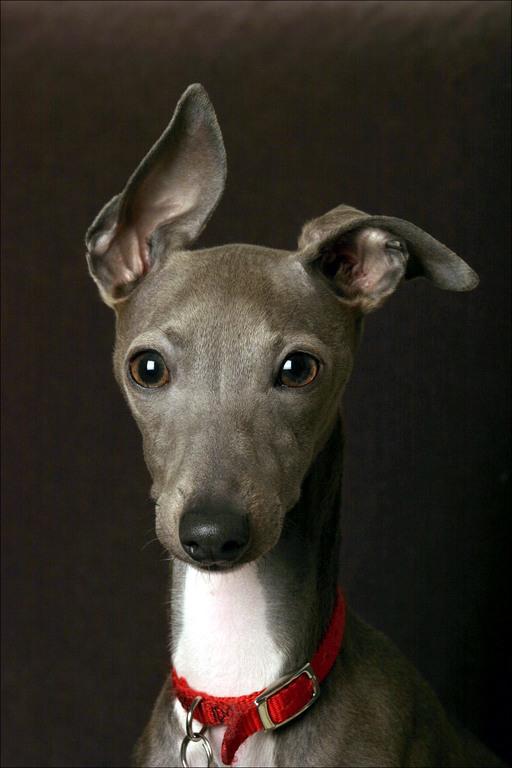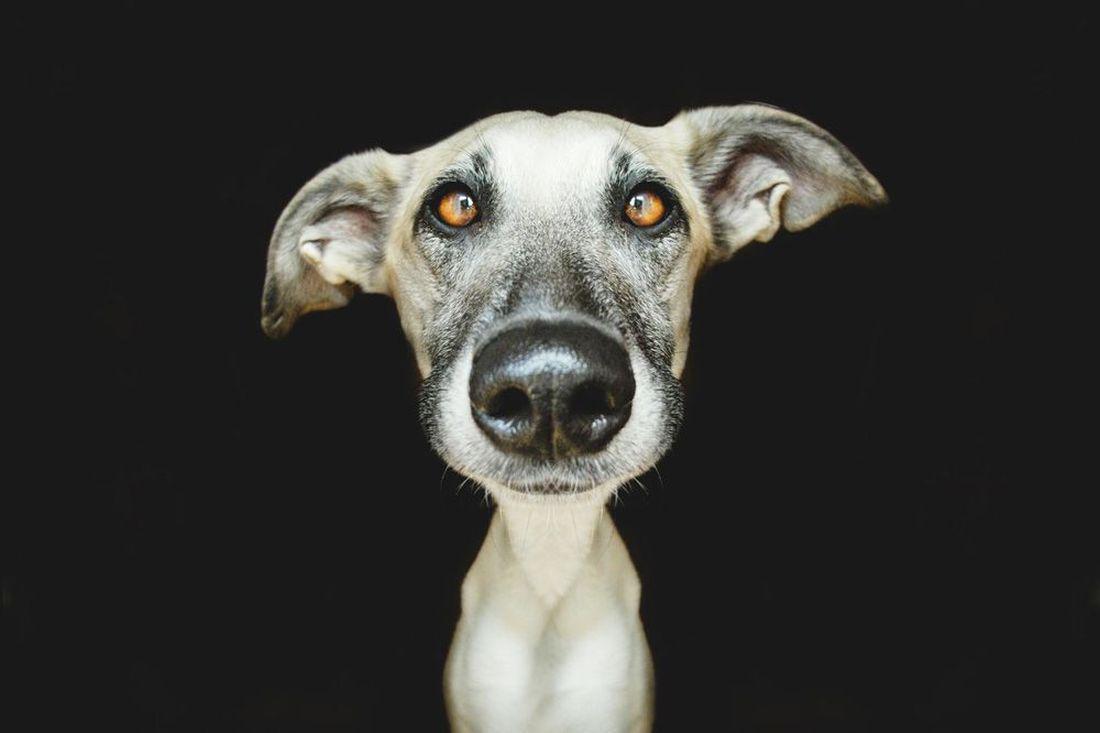The first image is the image on the left, the second image is the image on the right. Analyze the images presented: Is the assertion "Exactly one dog wears a bright red collar." valid? Answer yes or no. Yes. The first image is the image on the left, the second image is the image on the right. Evaluate the accuracy of this statement regarding the images: "A grayish hound with white chest marking is wearing a bright red collar.". Is it true? Answer yes or no. Yes. 